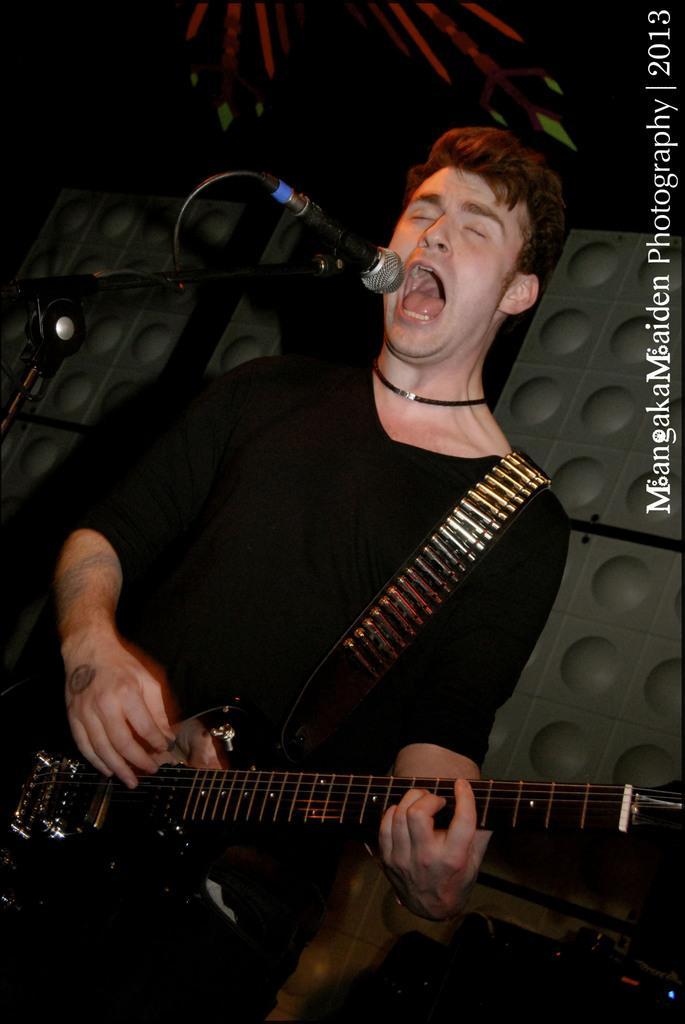Could you give a brief overview of what you see in this image? A man is playing a guitar and also singing on microphone. 